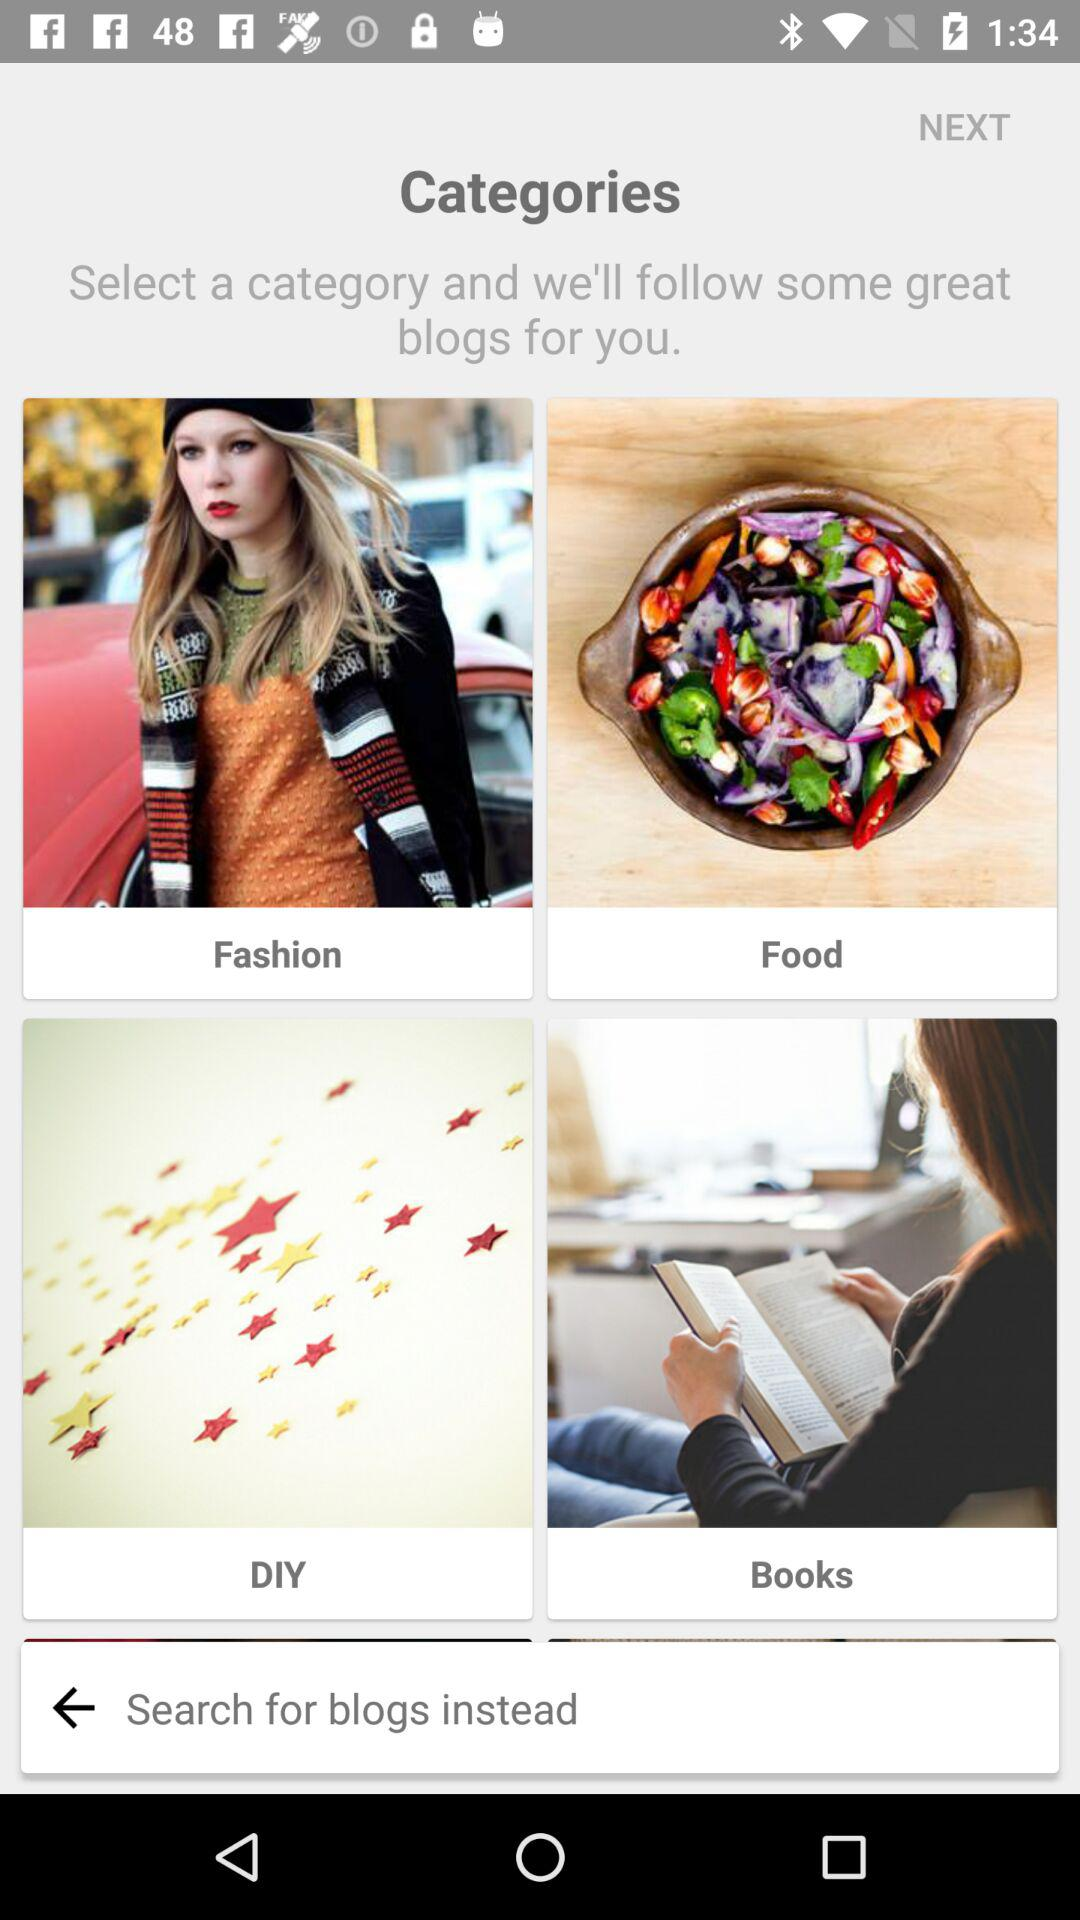How many categories are there?
Answer the question using a single word or phrase. 4 